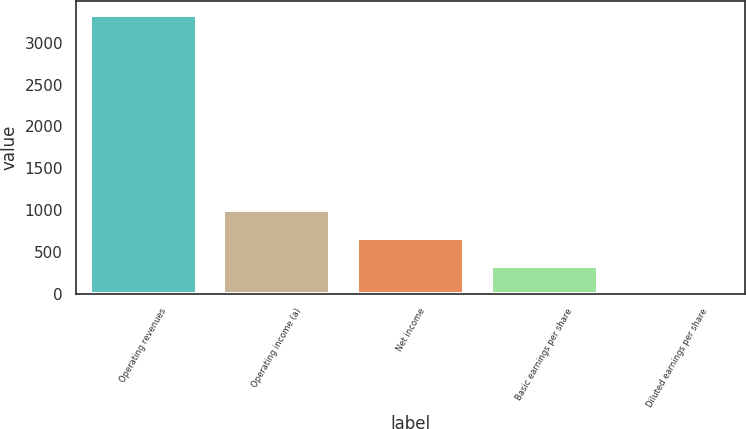Convert chart. <chart><loc_0><loc_0><loc_500><loc_500><bar_chart><fcel>Operating revenues<fcel>Operating income (a)<fcel>Net income<fcel>Basic earnings per share<fcel>Diluted earnings per share<nl><fcel>3328<fcel>999.37<fcel>666.71<fcel>334.05<fcel>1.39<nl></chart> 